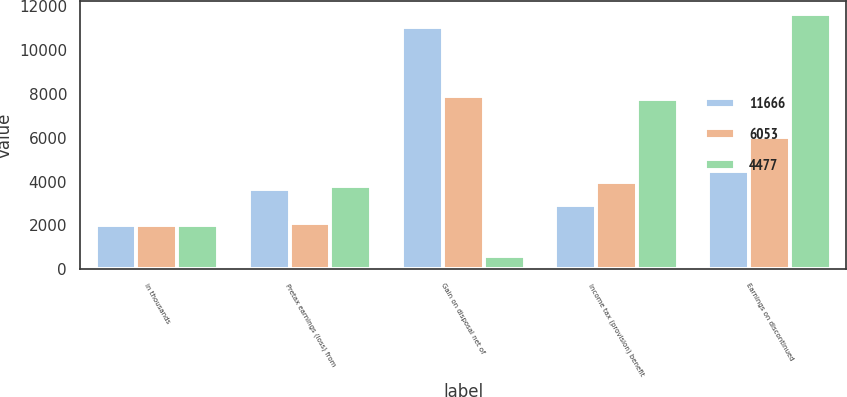<chart> <loc_0><loc_0><loc_500><loc_500><stacked_bar_chart><ecel><fcel>in thousands<fcel>Pretax earnings (loss) from<fcel>Gain on disposal net of<fcel>Income tax (provision) benefit<fcel>Earnings on discontinued<nl><fcel>11666<fcel>2011<fcel>3669<fcel>11056<fcel>2910<fcel>4477<nl><fcel>6053<fcel>2010<fcel>2103<fcel>7912<fcel>3962<fcel>6053<nl><fcel>4477<fcel>2009<fcel>3815.5<fcel>584<fcel>7790<fcel>11666<nl></chart> 